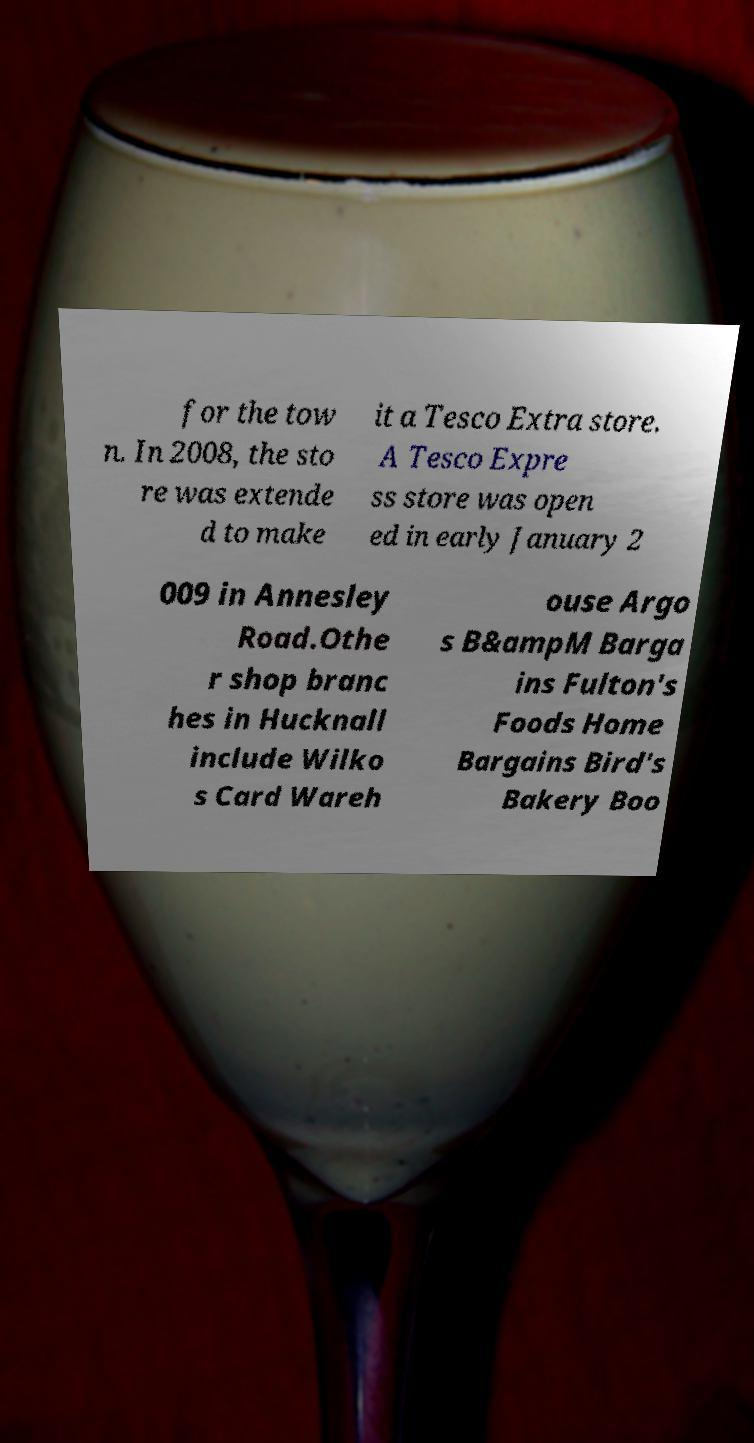Please read and relay the text visible in this image. What does it say? for the tow n. In 2008, the sto re was extende d to make it a Tesco Extra store. A Tesco Expre ss store was open ed in early January 2 009 in Annesley Road.Othe r shop branc hes in Hucknall include Wilko s Card Wareh ouse Argo s B&ampM Barga ins Fulton's Foods Home Bargains Bird's Bakery Boo 